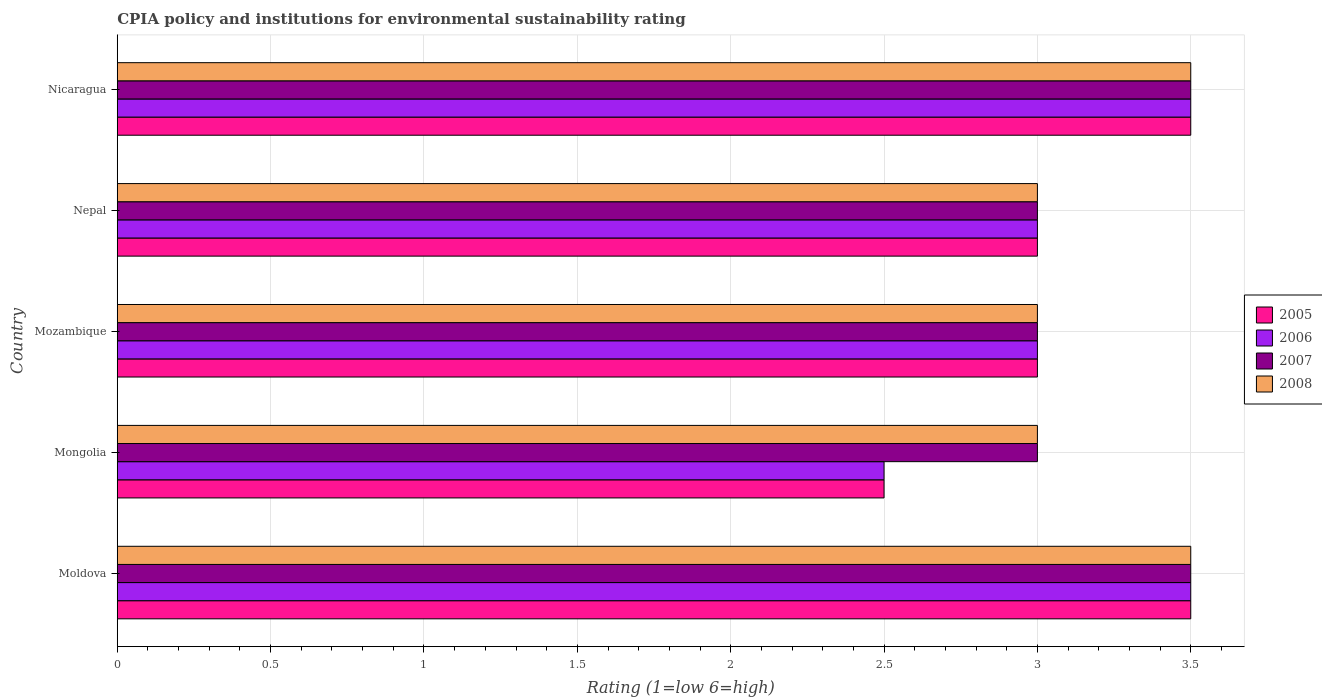Are the number of bars on each tick of the Y-axis equal?
Provide a succinct answer. Yes. How many bars are there on the 4th tick from the bottom?
Keep it short and to the point. 4. What is the label of the 3rd group of bars from the top?
Give a very brief answer. Mozambique. In which country was the CPIA rating in 2005 maximum?
Ensure brevity in your answer.  Moldova. In which country was the CPIA rating in 2006 minimum?
Your answer should be compact. Mongolia. What is the difference between the CPIA rating in 2007 in Moldova and that in Nicaragua?
Make the answer very short. 0. What is the average CPIA rating in 2007 per country?
Provide a succinct answer. 3.2. What is the ratio of the CPIA rating in 2008 in Mozambique to that in Nepal?
Provide a succinct answer. 1. What is the difference between the highest and the lowest CPIA rating in 2005?
Provide a short and direct response. 1. In how many countries, is the CPIA rating in 2005 greater than the average CPIA rating in 2005 taken over all countries?
Offer a terse response. 2. What does the 2nd bar from the top in Nepal represents?
Keep it short and to the point. 2007. What does the 2nd bar from the bottom in Nepal represents?
Offer a terse response. 2006. Is it the case that in every country, the sum of the CPIA rating in 2005 and CPIA rating in 2007 is greater than the CPIA rating in 2008?
Keep it short and to the point. Yes. Are all the bars in the graph horizontal?
Offer a terse response. Yes. Does the graph contain grids?
Make the answer very short. Yes. What is the title of the graph?
Ensure brevity in your answer.  CPIA policy and institutions for environmental sustainability rating. What is the Rating (1=low 6=high) of 2008 in Moldova?
Your answer should be compact. 3.5. What is the Rating (1=low 6=high) in 2005 in Mongolia?
Provide a short and direct response. 2.5. What is the Rating (1=low 6=high) in 2007 in Mongolia?
Your response must be concise. 3. What is the Rating (1=low 6=high) in 2006 in Mozambique?
Offer a very short reply. 3. What is the Rating (1=low 6=high) of 2008 in Mozambique?
Keep it short and to the point. 3. What is the Rating (1=low 6=high) of 2006 in Nepal?
Ensure brevity in your answer.  3. What is the Rating (1=low 6=high) of 2005 in Nicaragua?
Give a very brief answer. 3.5. What is the Rating (1=low 6=high) of 2008 in Nicaragua?
Offer a terse response. 3.5. Across all countries, what is the maximum Rating (1=low 6=high) of 2006?
Your response must be concise. 3.5. Across all countries, what is the maximum Rating (1=low 6=high) of 2007?
Keep it short and to the point. 3.5. Across all countries, what is the minimum Rating (1=low 6=high) in 2007?
Make the answer very short. 3. Across all countries, what is the minimum Rating (1=low 6=high) of 2008?
Offer a terse response. 3. What is the total Rating (1=low 6=high) in 2007 in the graph?
Ensure brevity in your answer.  16. What is the difference between the Rating (1=low 6=high) of 2005 in Moldova and that in Mongolia?
Keep it short and to the point. 1. What is the difference between the Rating (1=low 6=high) in 2008 in Moldova and that in Mongolia?
Make the answer very short. 0.5. What is the difference between the Rating (1=low 6=high) in 2006 in Moldova and that in Nepal?
Ensure brevity in your answer.  0.5. What is the difference between the Rating (1=low 6=high) of 2007 in Moldova and that in Nepal?
Your response must be concise. 0.5. What is the difference between the Rating (1=low 6=high) in 2006 in Moldova and that in Nicaragua?
Make the answer very short. 0. What is the difference between the Rating (1=low 6=high) of 2007 in Moldova and that in Nicaragua?
Keep it short and to the point. 0. What is the difference between the Rating (1=low 6=high) of 2005 in Mongolia and that in Mozambique?
Ensure brevity in your answer.  -0.5. What is the difference between the Rating (1=low 6=high) in 2006 in Mongolia and that in Mozambique?
Offer a very short reply. -0.5. What is the difference between the Rating (1=low 6=high) in 2006 in Mongolia and that in Nicaragua?
Give a very brief answer. -1. What is the difference between the Rating (1=low 6=high) of 2007 in Mongolia and that in Nicaragua?
Keep it short and to the point. -0.5. What is the difference between the Rating (1=low 6=high) in 2008 in Mongolia and that in Nicaragua?
Ensure brevity in your answer.  -0.5. What is the difference between the Rating (1=low 6=high) of 2008 in Mozambique and that in Nepal?
Keep it short and to the point. 0. What is the difference between the Rating (1=low 6=high) of 2006 in Mozambique and that in Nicaragua?
Ensure brevity in your answer.  -0.5. What is the difference between the Rating (1=low 6=high) in 2007 in Mozambique and that in Nicaragua?
Keep it short and to the point. -0.5. What is the difference between the Rating (1=low 6=high) of 2008 in Mozambique and that in Nicaragua?
Your answer should be compact. -0.5. What is the difference between the Rating (1=low 6=high) in 2005 in Nepal and that in Nicaragua?
Your response must be concise. -0.5. What is the difference between the Rating (1=low 6=high) in 2006 in Moldova and the Rating (1=low 6=high) in 2007 in Mongolia?
Keep it short and to the point. 0.5. What is the difference between the Rating (1=low 6=high) in 2006 in Moldova and the Rating (1=low 6=high) in 2008 in Mongolia?
Your answer should be very brief. 0.5. What is the difference between the Rating (1=low 6=high) in 2006 in Moldova and the Rating (1=low 6=high) in 2007 in Mozambique?
Make the answer very short. 0.5. What is the difference between the Rating (1=low 6=high) in 2006 in Moldova and the Rating (1=low 6=high) in 2008 in Mozambique?
Your answer should be compact. 0.5. What is the difference between the Rating (1=low 6=high) in 2007 in Moldova and the Rating (1=low 6=high) in 2008 in Mozambique?
Provide a short and direct response. 0.5. What is the difference between the Rating (1=low 6=high) of 2005 in Moldova and the Rating (1=low 6=high) of 2008 in Nepal?
Offer a terse response. 0.5. What is the difference between the Rating (1=low 6=high) in 2006 in Moldova and the Rating (1=low 6=high) in 2007 in Nepal?
Provide a short and direct response. 0.5. What is the difference between the Rating (1=low 6=high) in 2006 in Moldova and the Rating (1=low 6=high) in 2008 in Nepal?
Your answer should be very brief. 0.5. What is the difference between the Rating (1=low 6=high) in 2005 in Moldova and the Rating (1=low 6=high) in 2008 in Nicaragua?
Keep it short and to the point. 0. What is the difference between the Rating (1=low 6=high) of 2006 in Moldova and the Rating (1=low 6=high) of 2007 in Nicaragua?
Give a very brief answer. 0. What is the difference between the Rating (1=low 6=high) in 2006 in Moldova and the Rating (1=low 6=high) in 2008 in Nicaragua?
Your response must be concise. 0. What is the difference between the Rating (1=low 6=high) in 2006 in Mongolia and the Rating (1=low 6=high) in 2007 in Mozambique?
Give a very brief answer. -0.5. What is the difference between the Rating (1=low 6=high) in 2006 in Mongolia and the Rating (1=low 6=high) in 2008 in Mozambique?
Your answer should be very brief. -0.5. What is the difference between the Rating (1=low 6=high) of 2007 in Mongolia and the Rating (1=low 6=high) of 2008 in Mozambique?
Make the answer very short. 0. What is the difference between the Rating (1=low 6=high) in 2005 in Mongolia and the Rating (1=low 6=high) in 2006 in Nepal?
Offer a very short reply. -0.5. What is the difference between the Rating (1=low 6=high) in 2005 in Mongolia and the Rating (1=low 6=high) in 2007 in Nepal?
Provide a short and direct response. -0.5. What is the difference between the Rating (1=low 6=high) of 2006 in Mongolia and the Rating (1=low 6=high) of 2008 in Nepal?
Make the answer very short. -0.5. What is the difference between the Rating (1=low 6=high) of 2007 in Mongolia and the Rating (1=low 6=high) of 2008 in Nepal?
Offer a very short reply. 0. What is the difference between the Rating (1=low 6=high) in 2005 in Mongolia and the Rating (1=low 6=high) in 2006 in Nicaragua?
Your answer should be compact. -1. What is the difference between the Rating (1=low 6=high) in 2006 in Mongolia and the Rating (1=low 6=high) in 2007 in Nicaragua?
Your answer should be very brief. -1. What is the difference between the Rating (1=low 6=high) of 2007 in Mongolia and the Rating (1=low 6=high) of 2008 in Nicaragua?
Offer a very short reply. -0.5. What is the difference between the Rating (1=low 6=high) of 2005 in Mozambique and the Rating (1=low 6=high) of 2006 in Nepal?
Offer a terse response. 0. What is the difference between the Rating (1=low 6=high) of 2005 in Mozambique and the Rating (1=low 6=high) of 2007 in Nepal?
Your response must be concise. 0. What is the difference between the Rating (1=low 6=high) in 2005 in Mozambique and the Rating (1=low 6=high) in 2008 in Nepal?
Make the answer very short. 0. What is the difference between the Rating (1=low 6=high) in 2007 in Mozambique and the Rating (1=low 6=high) in 2008 in Nepal?
Keep it short and to the point. 0. What is the difference between the Rating (1=low 6=high) in 2005 in Mozambique and the Rating (1=low 6=high) in 2006 in Nicaragua?
Keep it short and to the point. -0.5. What is the difference between the Rating (1=low 6=high) in 2005 in Mozambique and the Rating (1=low 6=high) in 2008 in Nicaragua?
Provide a succinct answer. -0.5. What is the difference between the Rating (1=low 6=high) in 2005 in Nepal and the Rating (1=low 6=high) in 2006 in Nicaragua?
Make the answer very short. -0.5. What is the difference between the Rating (1=low 6=high) in 2005 in Nepal and the Rating (1=low 6=high) in 2007 in Nicaragua?
Offer a very short reply. -0.5. What is the difference between the Rating (1=low 6=high) of 2005 in Nepal and the Rating (1=low 6=high) of 2008 in Nicaragua?
Your answer should be compact. -0.5. What is the difference between the Rating (1=low 6=high) in 2007 in Nepal and the Rating (1=low 6=high) in 2008 in Nicaragua?
Ensure brevity in your answer.  -0.5. What is the average Rating (1=low 6=high) in 2005 per country?
Make the answer very short. 3.1. What is the average Rating (1=low 6=high) in 2006 per country?
Keep it short and to the point. 3.1. What is the difference between the Rating (1=low 6=high) of 2005 and Rating (1=low 6=high) of 2006 in Moldova?
Your answer should be very brief. 0. What is the difference between the Rating (1=low 6=high) in 2005 and Rating (1=low 6=high) in 2007 in Moldova?
Give a very brief answer. 0. What is the difference between the Rating (1=low 6=high) of 2005 and Rating (1=low 6=high) of 2008 in Moldova?
Provide a short and direct response. 0. What is the difference between the Rating (1=low 6=high) of 2006 and Rating (1=low 6=high) of 2007 in Moldova?
Give a very brief answer. 0. What is the difference between the Rating (1=low 6=high) of 2007 and Rating (1=low 6=high) of 2008 in Moldova?
Your answer should be compact. 0. What is the difference between the Rating (1=low 6=high) in 2005 and Rating (1=low 6=high) in 2007 in Mongolia?
Offer a terse response. -0.5. What is the difference between the Rating (1=low 6=high) of 2006 and Rating (1=low 6=high) of 2007 in Mongolia?
Offer a terse response. -0.5. What is the difference between the Rating (1=low 6=high) in 2006 and Rating (1=low 6=high) in 2008 in Mozambique?
Give a very brief answer. 0. What is the difference between the Rating (1=low 6=high) in 2005 and Rating (1=low 6=high) in 2007 in Nepal?
Provide a succinct answer. 0. What is the difference between the Rating (1=low 6=high) in 2006 and Rating (1=low 6=high) in 2008 in Nepal?
Provide a short and direct response. 0. What is the difference between the Rating (1=low 6=high) in 2007 and Rating (1=low 6=high) in 2008 in Nepal?
Provide a succinct answer. 0. What is the difference between the Rating (1=low 6=high) of 2005 and Rating (1=low 6=high) of 2006 in Nicaragua?
Ensure brevity in your answer.  0. What is the difference between the Rating (1=low 6=high) of 2006 and Rating (1=low 6=high) of 2008 in Nicaragua?
Your answer should be compact. 0. What is the difference between the Rating (1=low 6=high) in 2007 and Rating (1=low 6=high) in 2008 in Nicaragua?
Provide a succinct answer. 0. What is the ratio of the Rating (1=low 6=high) in 2005 in Moldova to that in Mongolia?
Your response must be concise. 1.4. What is the ratio of the Rating (1=low 6=high) of 2006 in Moldova to that in Mongolia?
Your response must be concise. 1.4. What is the ratio of the Rating (1=low 6=high) of 2007 in Moldova to that in Mongolia?
Provide a short and direct response. 1.17. What is the ratio of the Rating (1=low 6=high) of 2005 in Moldova to that in Mozambique?
Offer a very short reply. 1.17. What is the ratio of the Rating (1=low 6=high) in 2008 in Moldova to that in Mozambique?
Offer a very short reply. 1.17. What is the ratio of the Rating (1=low 6=high) of 2005 in Moldova to that in Nepal?
Offer a terse response. 1.17. What is the ratio of the Rating (1=low 6=high) of 2008 in Moldova to that in Nepal?
Your answer should be compact. 1.17. What is the ratio of the Rating (1=low 6=high) of 2005 in Moldova to that in Nicaragua?
Provide a short and direct response. 1. What is the ratio of the Rating (1=low 6=high) in 2006 in Moldova to that in Nicaragua?
Your response must be concise. 1. What is the ratio of the Rating (1=low 6=high) of 2008 in Moldova to that in Nicaragua?
Provide a succinct answer. 1. What is the ratio of the Rating (1=low 6=high) in 2005 in Mongolia to that in Mozambique?
Keep it short and to the point. 0.83. What is the ratio of the Rating (1=low 6=high) of 2006 in Mongolia to that in Mozambique?
Make the answer very short. 0.83. What is the ratio of the Rating (1=low 6=high) of 2008 in Mongolia to that in Mozambique?
Your answer should be very brief. 1. What is the ratio of the Rating (1=low 6=high) of 2006 in Mongolia to that in Nepal?
Your answer should be very brief. 0.83. What is the ratio of the Rating (1=low 6=high) in 2008 in Mongolia to that in Nepal?
Offer a very short reply. 1. What is the ratio of the Rating (1=low 6=high) in 2007 in Mongolia to that in Nicaragua?
Keep it short and to the point. 0.86. What is the ratio of the Rating (1=low 6=high) in 2008 in Mongolia to that in Nicaragua?
Ensure brevity in your answer.  0.86. What is the ratio of the Rating (1=low 6=high) of 2008 in Mozambique to that in Nepal?
Provide a short and direct response. 1. What is the ratio of the Rating (1=low 6=high) in 2007 in Mozambique to that in Nicaragua?
Provide a short and direct response. 0.86. What is the ratio of the Rating (1=low 6=high) of 2005 in Nepal to that in Nicaragua?
Give a very brief answer. 0.86. What is the ratio of the Rating (1=low 6=high) of 2006 in Nepal to that in Nicaragua?
Ensure brevity in your answer.  0.86. What is the ratio of the Rating (1=low 6=high) in 2008 in Nepal to that in Nicaragua?
Your answer should be very brief. 0.86. What is the difference between the highest and the second highest Rating (1=low 6=high) of 2005?
Ensure brevity in your answer.  0. What is the difference between the highest and the second highest Rating (1=low 6=high) of 2007?
Ensure brevity in your answer.  0. What is the difference between the highest and the second highest Rating (1=low 6=high) of 2008?
Give a very brief answer. 0. What is the difference between the highest and the lowest Rating (1=low 6=high) of 2005?
Provide a short and direct response. 1. What is the difference between the highest and the lowest Rating (1=low 6=high) in 2007?
Provide a short and direct response. 0.5. 